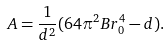<formula> <loc_0><loc_0><loc_500><loc_500>A = \frac { 1 } { d ^ { 2 } } ( 6 4 \pi ^ { 2 } B r _ { 0 } ^ { 4 } - d ) .</formula> 